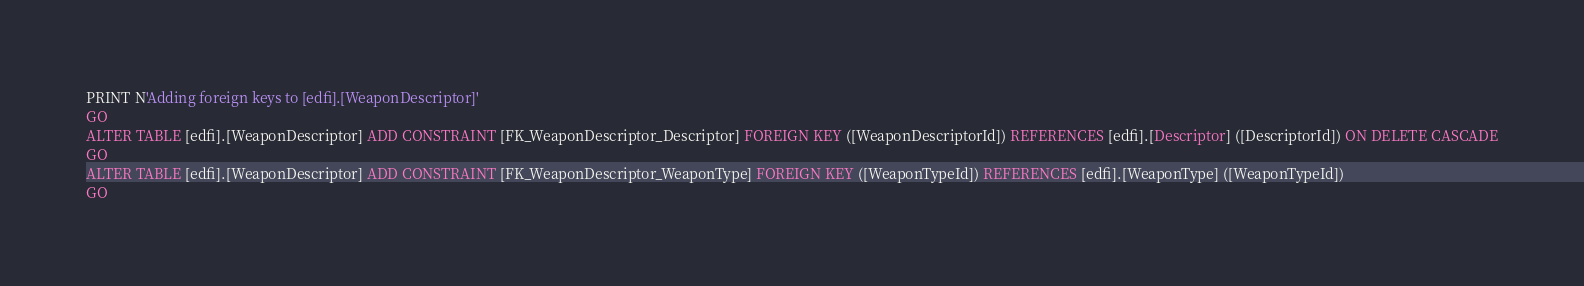<code> <loc_0><loc_0><loc_500><loc_500><_SQL_>
PRINT N'Adding foreign keys to [edfi].[WeaponDescriptor]'
GO
ALTER TABLE [edfi].[WeaponDescriptor] ADD CONSTRAINT [FK_WeaponDescriptor_Descriptor] FOREIGN KEY ([WeaponDescriptorId]) REFERENCES [edfi].[Descriptor] ([DescriptorId]) ON DELETE CASCADE
GO
ALTER TABLE [edfi].[WeaponDescriptor] ADD CONSTRAINT [FK_WeaponDescriptor_WeaponType] FOREIGN KEY ([WeaponTypeId]) REFERENCES [edfi].[WeaponType] ([WeaponTypeId])
GO
</code> 